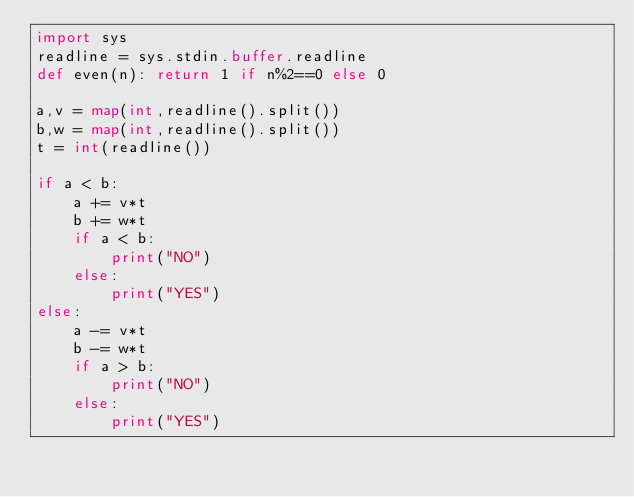<code> <loc_0><loc_0><loc_500><loc_500><_Python_>import sys
readline = sys.stdin.buffer.readline
def even(n): return 1 if n%2==0 else 0

a,v = map(int,readline().split())
b,w = map(int,readline().split())
t = int(readline())

if a < b:
    a += v*t
    b += w*t
    if a < b:
        print("NO")
    else:
        print("YES")
else:
    a -= v*t
    b -= w*t
    if a > b:
        print("NO")
    else:
        print("YES")
</code> 